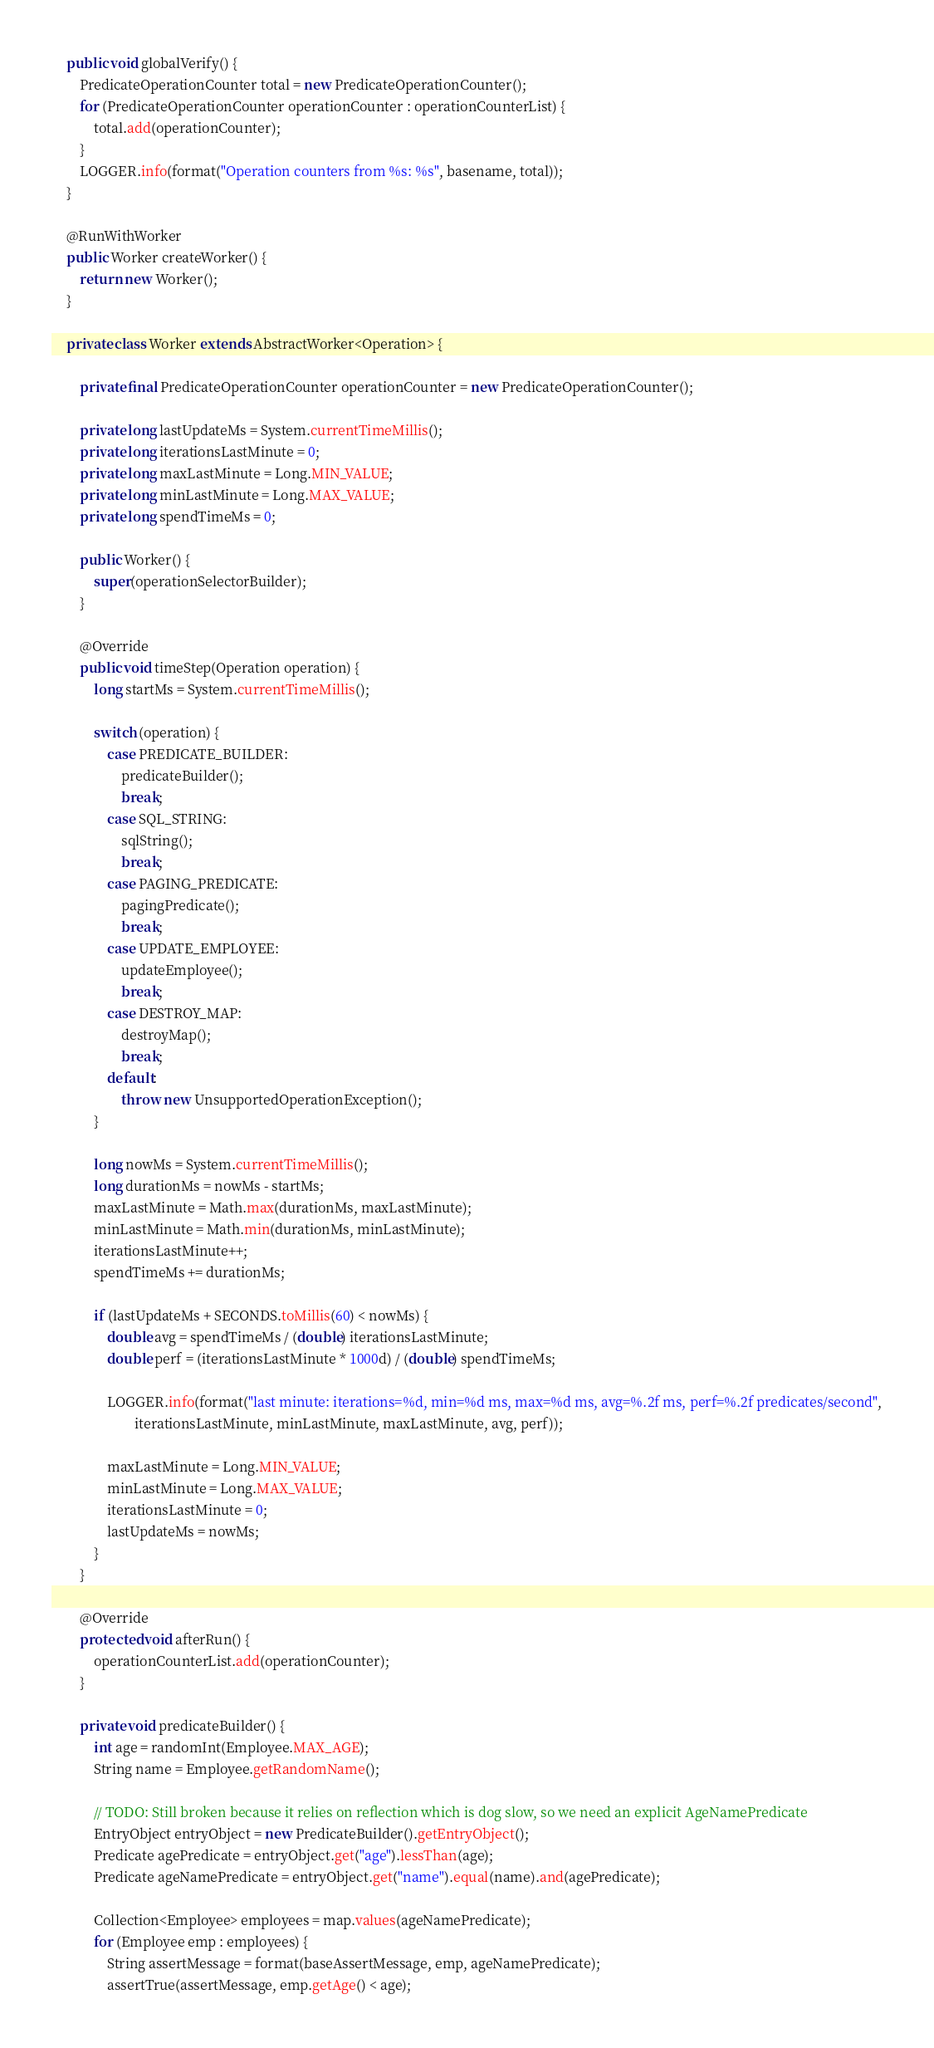<code> <loc_0><loc_0><loc_500><loc_500><_Java_>    public void globalVerify() {
        PredicateOperationCounter total = new PredicateOperationCounter();
        for (PredicateOperationCounter operationCounter : operationCounterList) {
            total.add(operationCounter);
        }
        LOGGER.info(format("Operation counters from %s: %s", basename, total));
    }

    @RunWithWorker
    public Worker createWorker() {
        return new Worker();
    }

    private class Worker extends AbstractWorker<Operation> {

        private final PredicateOperationCounter operationCounter = new PredicateOperationCounter();

        private long lastUpdateMs = System.currentTimeMillis();
        private long iterationsLastMinute = 0;
        private long maxLastMinute = Long.MIN_VALUE;
        private long minLastMinute = Long.MAX_VALUE;
        private long spendTimeMs = 0;

        public Worker() {
            super(operationSelectorBuilder);
        }

        @Override
        public void timeStep(Operation operation) {
            long startMs = System.currentTimeMillis();

            switch (operation) {
                case PREDICATE_BUILDER:
                    predicateBuilder();
                    break;
                case SQL_STRING:
                    sqlString();
                    break;
                case PAGING_PREDICATE:
                    pagingPredicate();
                    break;
                case UPDATE_EMPLOYEE:
                    updateEmployee();
                    break;
                case DESTROY_MAP:
                    destroyMap();
                    break;
                default:
                    throw new UnsupportedOperationException();
            }

            long nowMs = System.currentTimeMillis();
            long durationMs = nowMs - startMs;
            maxLastMinute = Math.max(durationMs, maxLastMinute);
            minLastMinute = Math.min(durationMs, minLastMinute);
            iterationsLastMinute++;
            spendTimeMs += durationMs;

            if (lastUpdateMs + SECONDS.toMillis(60) < nowMs) {
                double avg = spendTimeMs / (double) iterationsLastMinute;
                double perf = (iterationsLastMinute * 1000d) / (double) spendTimeMs;

                LOGGER.info(format("last minute: iterations=%d, min=%d ms, max=%d ms, avg=%.2f ms, perf=%.2f predicates/second",
                        iterationsLastMinute, minLastMinute, maxLastMinute, avg, perf));

                maxLastMinute = Long.MIN_VALUE;
                minLastMinute = Long.MAX_VALUE;
                iterationsLastMinute = 0;
                lastUpdateMs = nowMs;
            }
        }

        @Override
        protected void afterRun() {
            operationCounterList.add(operationCounter);
        }

        private void predicateBuilder() {
            int age = randomInt(Employee.MAX_AGE);
            String name = Employee.getRandomName();

            // TODO: Still broken because it relies on reflection which is dog slow, so we need an explicit AgeNamePredicate
            EntryObject entryObject = new PredicateBuilder().getEntryObject();
            Predicate agePredicate = entryObject.get("age").lessThan(age);
            Predicate ageNamePredicate = entryObject.get("name").equal(name).and(agePredicate);

            Collection<Employee> employees = map.values(ageNamePredicate);
            for (Employee emp : employees) {
                String assertMessage = format(baseAssertMessage, emp, ageNamePredicate);
                assertTrue(assertMessage, emp.getAge() < age);</code> 